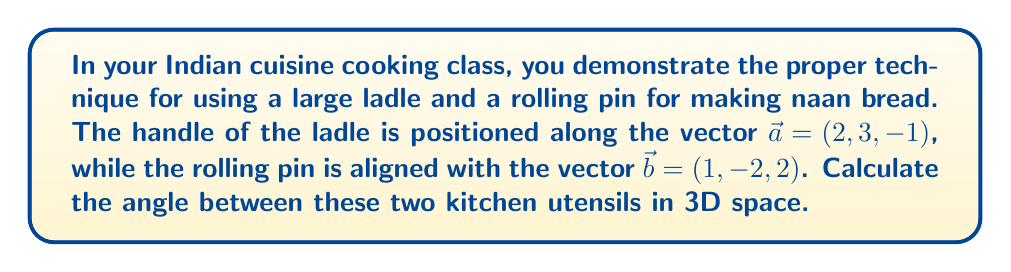Can you solve this math problem? To find the angle between two vectors in 3D space, we can use the dot product formula:

$$\cos \theta = \frac{\vec{a} \cdot \vec{b}}{|\vec{a}||\vec{b}|}$$

Where $\theta$ is the angle between the vectors, $\vec{a} \cdot \vec{b}$ is the dot product of the vectors, and $|\vec{a}|$ and $|\vec{b}|$ are the magnitudes of the vectors.

Step 1: Calculate the dot product $\vec{a} \cdot \vec{b}$
$$\vec{a} \cdot \vec{b} = (2)(1) + (3)(-2) + (-1)(2) = 2 - 6 - 2 = -6$$

Step 2: Calculate the magnitudes of $\vec{a}$ and $\vec{b}$
$$|\vec{a}| = \sqrt{2^2 + 3^2 + (-1)^2} = \sqrt{4 + 9 + 1} = \sqrt{14}$$
$$|\vec{b}| = \sqrt{1^2 + (-2)^2 + 2^2} = \sqrt{1 + 4 + 4} = 3$$

Step 3: Substitute into the dot product formula
$$\cos \theta = \frac{-6}{\sqrt{14} \cdot 3}$$

Step 4: Solve for $\theta$ using the inverse cosine function
$$\theta = \arccos\left(\frac{-6}{\sqrt{14} \cdot 3}\right)$$

Step 5: Calculate the final answer
$$\theta \approx 2.0344 \text{ radians} \approx 116.57°$$
Answer: The angle between the ladle and the rolling pin is approximately 116.57°. 